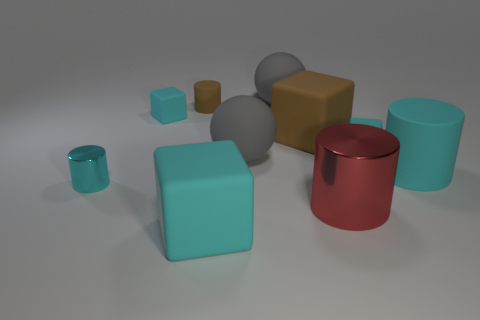Is the color of the block in front of the big cyan cylinder the same as the large matte cylinder?
Keep it short and to the point. Yes. There is a big matte block in front of the tiny cyan cylinder; is its color the same as the tiny matte cube to the right of the big brown cube?
Make the answer very short. Yes. Are there fewer large cyan rubber objects than purple rubber balls?
Offer a very short reply. No. What shape is the rubber object left of the tiny cylinder that is behind the big brown thing?
Provide a succinct answer. Cube. What shape is the large cyan rubber thing in front of the tiny object in front of the big thing that is right of the large red metal object?
Your answer should be very brief. Cube. How many things are either big cyan matte things in front of the red cylinder or things that are in front of the large shiny cylinder?
Your answer should be compact. 1. Do the cyan metal cylinder and the brown cylinder that is on the left side of the red metal thing have the same size?
Your answer should be very brief. Yes. Does the red thing on the left side of the large cyan matte cylinder have the same material as the big brown thing behind the red metallic cylinder?
Make the answer very short. No. Are there the same number of tiny cylinders that are on the right side of the big cyan matte cylinder and small brown objects that are in front of the big shiny object?
Offer a very short reply. Yes. How many other objects are the same color as the tiny metallic object?
Keep it short and to the point. 4. 